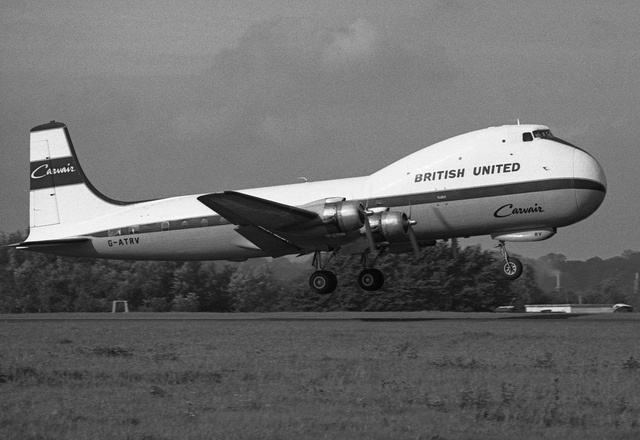Describe the objects in this image and their specific colors. I can see a airplane in gray, black, lightgray, and darkgray tones in this image. 